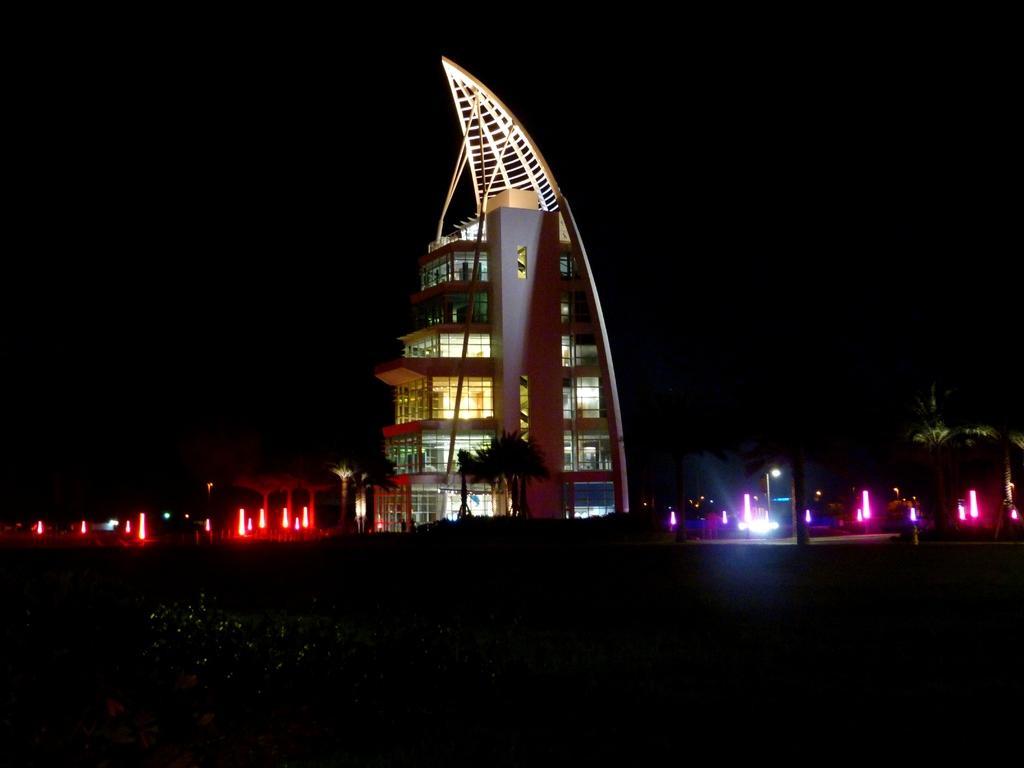Could you give a brief overview of what you see in this image? In the picture we can see a night view of the building which is in the shape of a triangle with different floors and glasses to it and besides the building we can see some constructions with red color lights and some constructions with pink color lighting near it. 